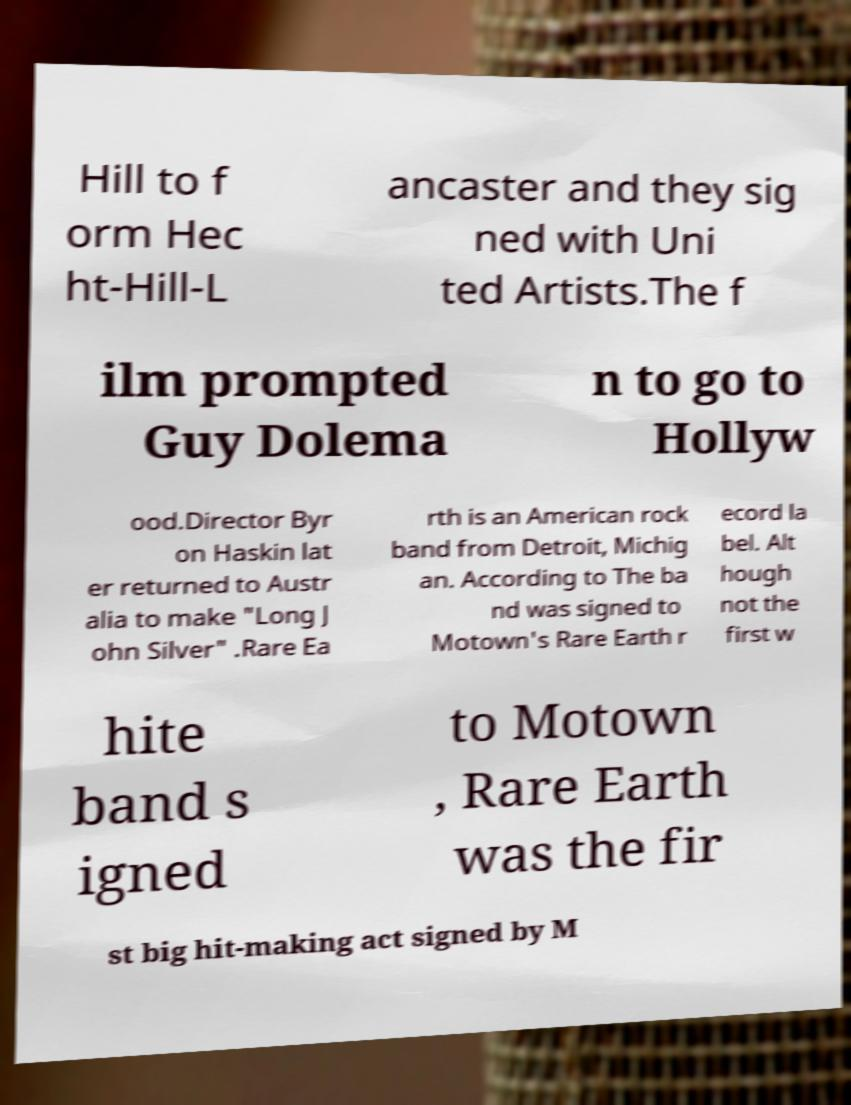I need the written content from this picture converted into text. Can you do that? Hill to f orm Hec ht-Hill-L ancaster and they sig ned with Uni ted Artists.The f ilm prompted Guy Dolema n to go to Hollyw ood.Director Byr on Haskin lat er returned to Austr alia to make "Long J ohn Silver" .Rare Ea rth is an American rock band from Detroit, Michig an. According to The ba nd was signed to Motown's Rare Earth r ecord la bel. Alt hough not the first w hite band s igned to Motown , Rare Earth was the fir st big hit-making act signed by M 